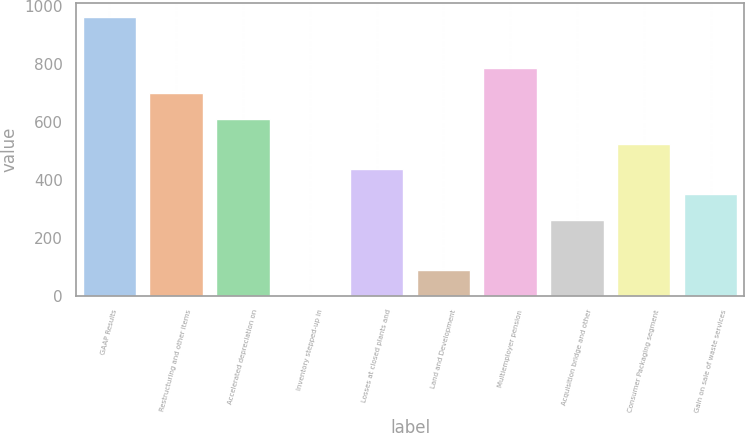Convert chart. <chart><loc_0><loc_0><loc_500><loc_500><bar_chart><fcel>GAAP Results<fcel>Restructuring and other items<fcel>Accelerated depreciation on<fcel>Inventory stepped-up in<fcel>Losses at closed plants and<fcel>Land and Development<fcel>Multiemployer pension<fcel>Acquisition bridge and other<fcel>Consumer Packaging segment<fcel>Gain on sale of waste services<nl><fcel>961.92<fcel>699.66<fcel>612.24<fcel>0.3<fcel>437.4<fcel>87.72<fcel>787.08<fcel>262.56<fcel>524.82<fcel>349.98<nl></chart> 